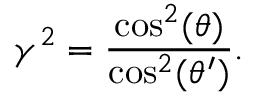<formula> <loc_0><loc_0><loc_500><loc_500>\gamma ^ { 2 } = \frac { \cos ^ { 2 } ( \theta ) } { \cos ^ { 2 } ( \theta ^ { \prime } ) } .</formula> 